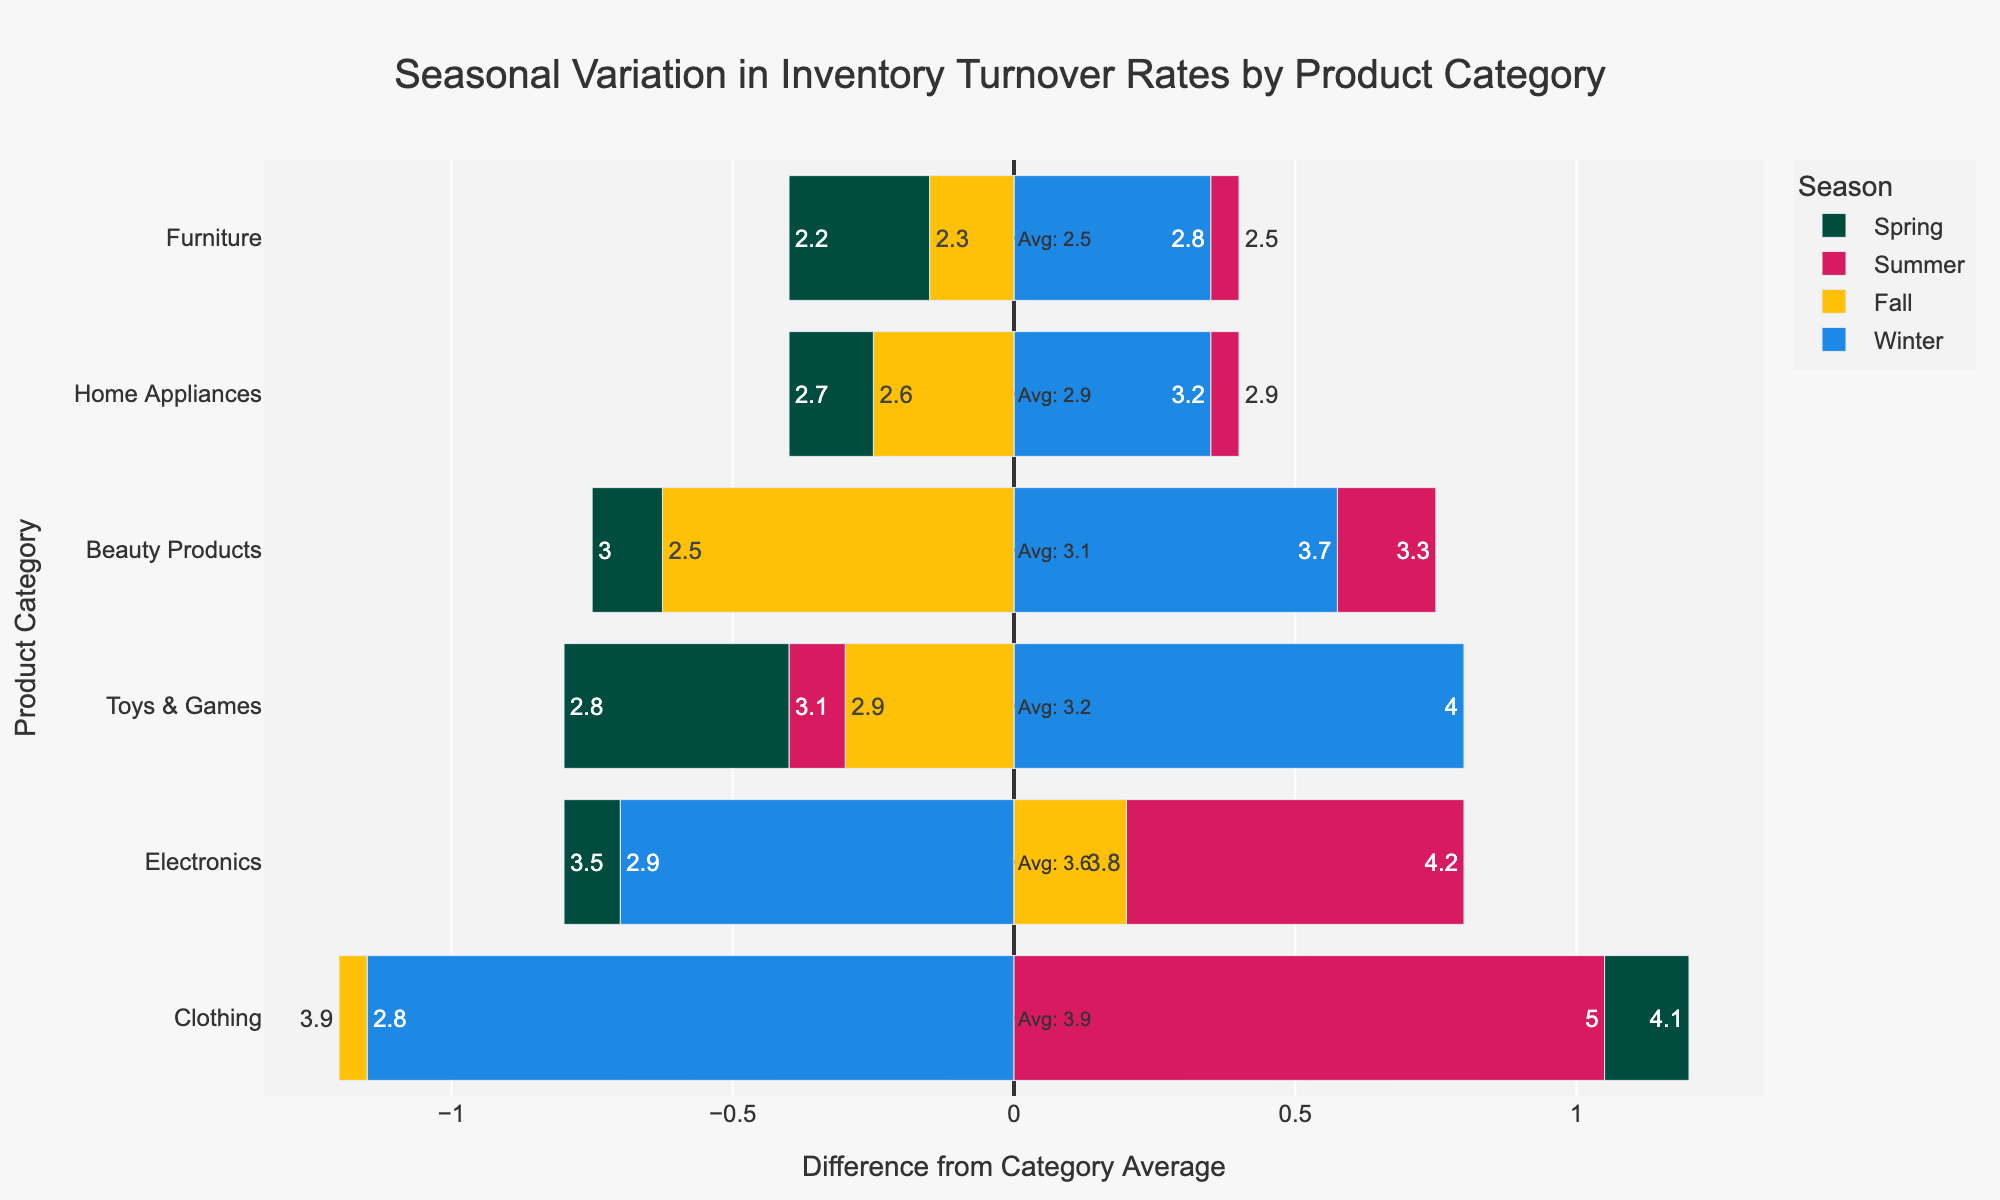What's the average Inventory Turnover Rate for Electronics? Look at the average line annotation next to the "Electronics" category on the plot; it will show the average value.
Answer: 3.6 Which product category has the highest inventory turnover rate in the Summer? The highest bar in the Summer (red) segment represents the highest inventory turnover rate. Compare the lengths of these bars.
Answer: Clothing Is the Inventory Turnover Rate for Home Appliances in Winter above or below its category average? Check the relative position of the Winter (blue) segment for Home Appliances against the zero line which indicates the average.
Answer: Above How does the Inventory Turnover Rate for Furniture in Spring compare to its category average? Observe the length and position of the Spring (green) bar for Furniture in relation to the zero line.
Answer: Below Which season has the most instances of above-average turnover rates across all product categories? Count the number of bars extending to the right (above average) for each season (unique color).
Answer: Summer For the Toys & Games category, what is the difference in Inventory Turnover Rate between Winter and Fall? Compare the Winter (blue) and Fall (yellow) bars for Toys & Games, subtract the Fall rate from the Winter rate.
Answer: 1.1 Which product category shows the greatest seasonal variation in Inventory Turnover Rates? Compare the total span of bars (difference from average) for each category. The category with the widest spread indicates the most variation.
Answer: Toys & Games Are Inventory Turnover Rates for Beauty Products generally higher in Winter compared to Spring? Compare the Winter (blue) and Spring (green) bars for Beauty Products. Note their relative lengths.
Answer: Yes What is the difference between the highest Inventory Turnover Rate and the lowest Inventory Turnover Rate for Clothing across all seasons? Identify the maximum and minimum bar lengths for Clothing and subtract the smallest value from the largest.
Answer: 2.2 Which season's bar is generally shorter for Home Appliances, indicating a closer to average Inventory Turnover Rate? Examine the bar lengths for Home Appliances across all seasons and identify the shortest bar.
Answer: Fall 